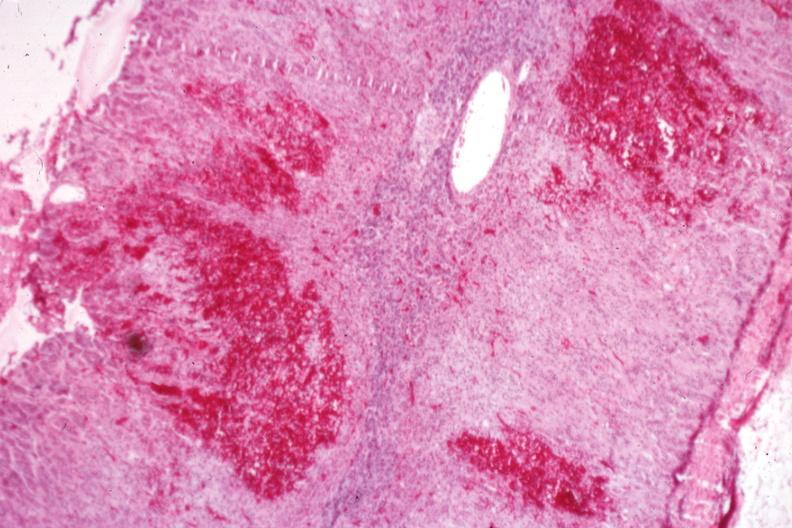s endocrine present?
Answer the question using a single word or phrase. Yes 